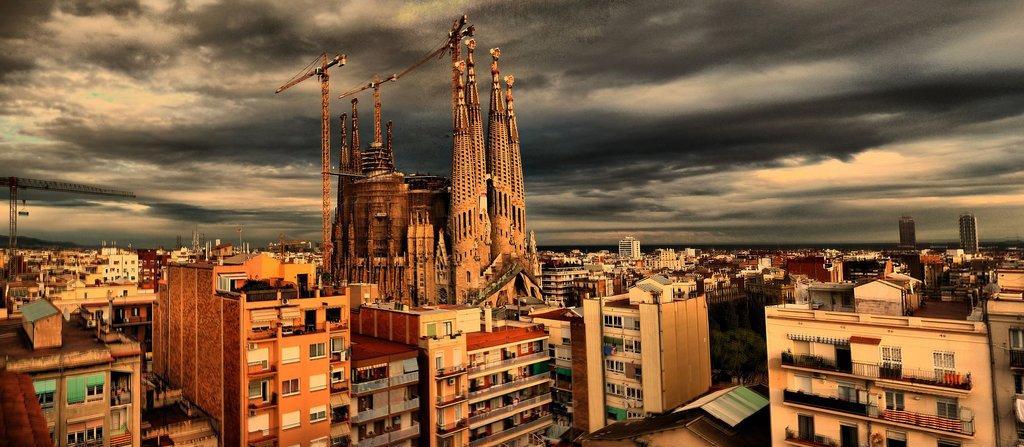Please provide a concise description of this image. In the center of the image we can see buildings, towers, shed, trees, grills, windows, wall are there. At the top of the image clouds are present in the sky. 